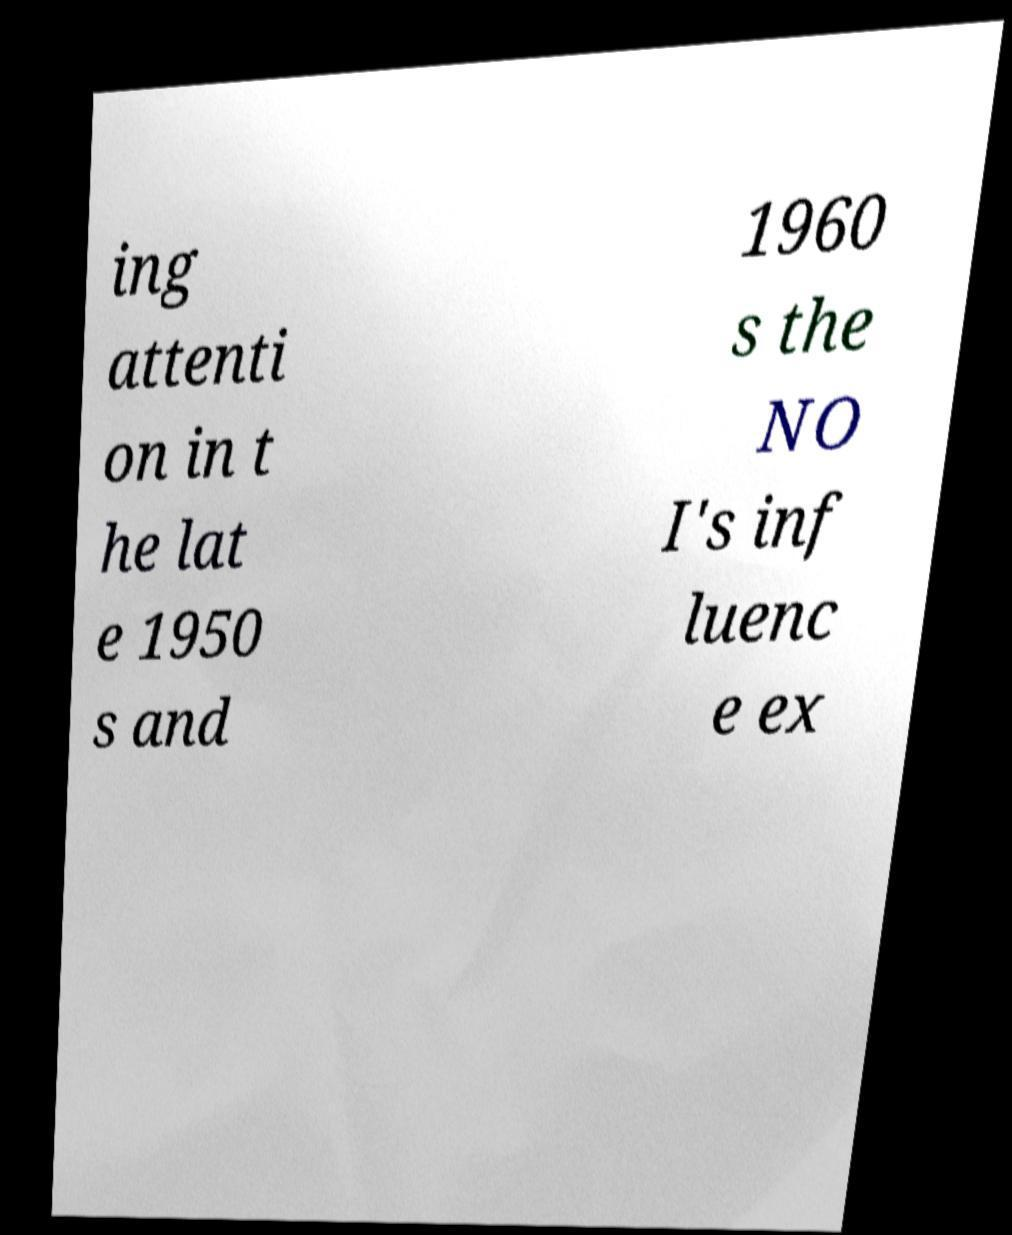Can you read and provide the text displayed in the image?This photo seems to have some interesting text. Can you extract and type it out for me? ing attenti on in t he lat e 1950 s and 1960 s the NO I's inf luenc e ex 